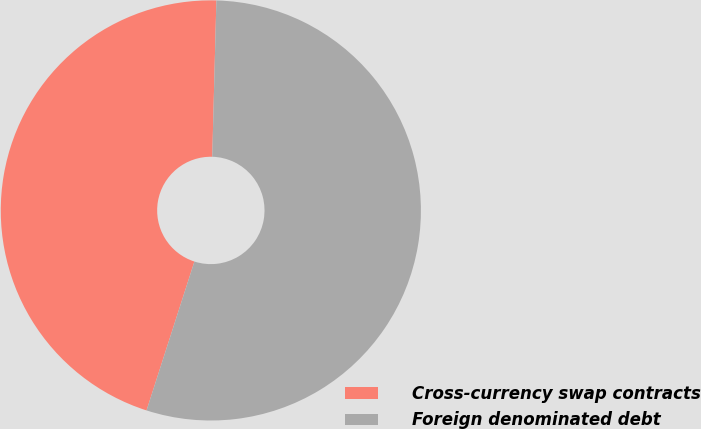Convert chart. <chart><loc_0><loc_0><loc_500><loc_500><pie_chart><fcel>Cross-currency swap contracts<fcel>Foreign denominated debt<nl><fcel>45.47%<fcel>54.53%<nl></chart> 